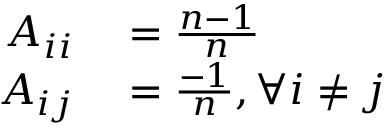<formula> <loc_0><loc_0><loc_500><loc_500>\begin{array} { r l } { A _ { i i } } & = \frac { n - 1 } { n } } \\ { A _ { i j } } & = \frac { - 1 } { n } , \forall i \neq j } \end{array}</formula> 